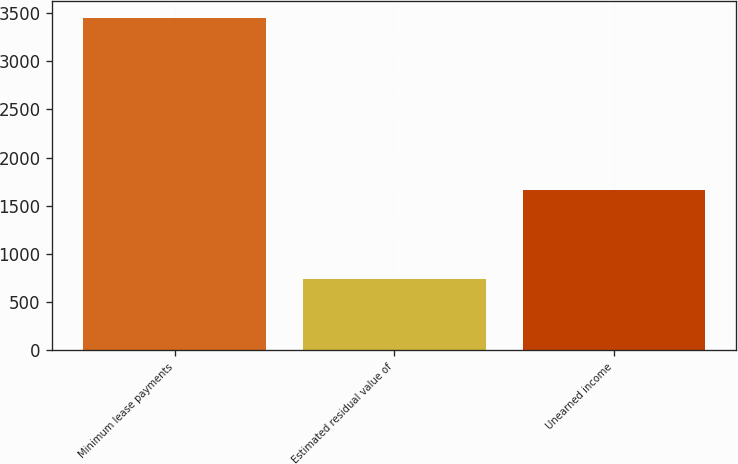<chart> <loc_0><loc_0><loc_500><loc_500><bar_chart><fcel>Minimum lease payments<fcel>Estimated residual value of<fcel>Unearned income<nl><fcel>3451<fcel>735<fcel>1658<nl></chart> 